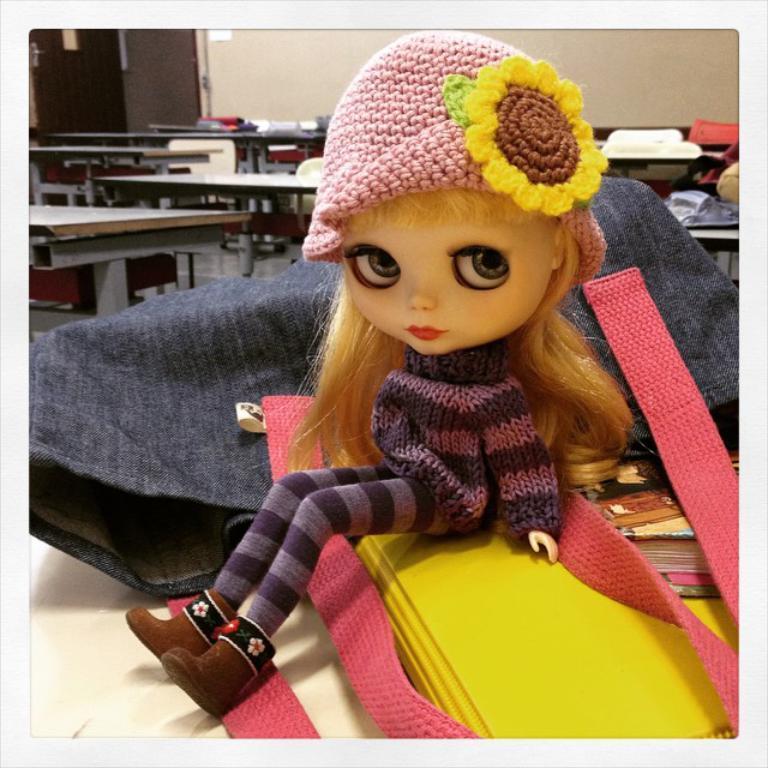Describe this image in one or two sentences. This picture is clicked inside the room. In the foreground we can see a doll sitting and we can see a cloth and some other objects and a book are placed on the top of the table. In the background we can see the wall, doors, tables, chairs and many other objects. 